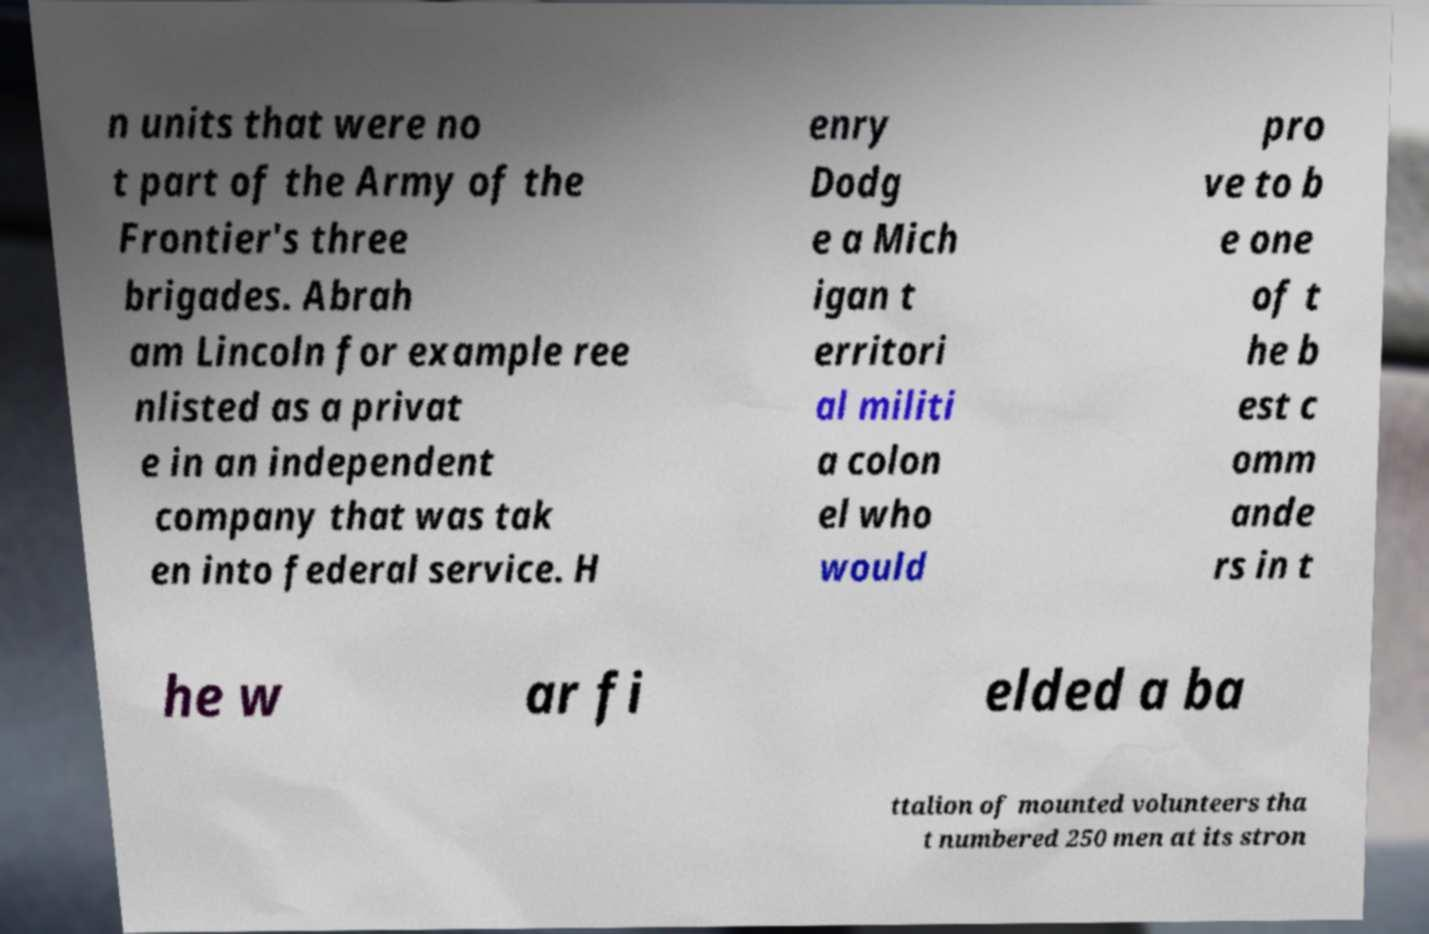For documentation purposes, I need the text within this image transcribed. Could you provide that? n units that were no t part of the Army of the Frontier's three brigades. Abrah am Lincoln for example ree nlisted as a privat e in an independent company that was tak en into federal service. H enry Dodg e a Mich igan t erritori al militi a colon el who would pro ve to b e one of t he b est c omm ande rs in t he w ar fi elded a ba ttalion of mounted volunteers tha t numbered 250 men at its stron 